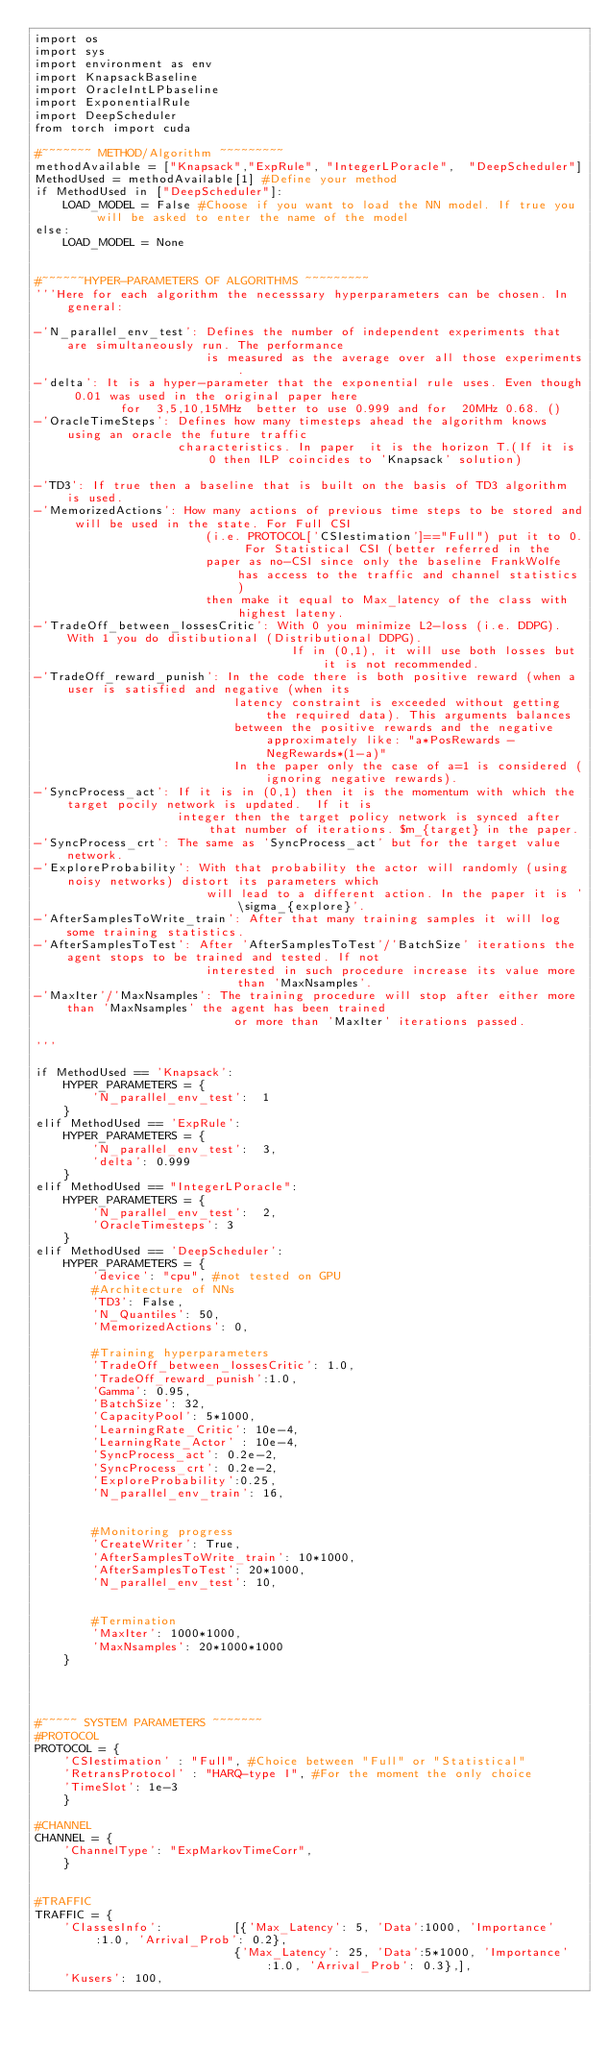<code> <loc_0><loc_0><loc_500><loc_500><_Python_>import os
import sys
import environment as env
import KnapsackBaseline
import OracleIntLPbaseline
import ExponentialRule
import DeepScheduler
from torch import cuda

#~~~~~~~ METHOD/Algorithm ~~~~~~~~~  
methodAvailable = ["Knapsack","ExpRule", "IntegerLPoracle",  "DeepScheduler"]
MethodUsed = methodAvailable[1] #Define your method
if MethodUsed in ["DeepScheduler"]:
    LOAD_MODEL = False #Choose if you want to load the NN model. If true you will be asked to enter the name of the model
else: 
    LOAD_MODEL = None


#~~~~~~HYPER-PARAMETERS OF ALGORITHMS ~~~~~~~~~
'''Here for each algorithm the necesssary hyperparameters can be chosen. In general:

-'N_parallel_env_test': Defines the number of independent experiments that are simultaneously run. The performance 
                        is measured as the average over all those experiments.
-'delta': It is a hyper-parameter that the exponential rule uses. Even though 0.01 was used in the original paper here
            for  3,5,10,15MHz  better to use 0.999 and for  20MHz 0.68. ()
-'OracleTimeSteps': Defines how many timesteps ahead the algorithm knows using an oracle the future traffic 
                    characteristics. In paper  it is the horizon T.(If it is 0 then ILP coincides to 'Knapsack' solution)

-'TD3': If true then a baseline that is built on the basis of TD3 algorithm is used.
-'MemorizedActions': How many actions of previous time steps to be stored and will be used in the state. For Full CSI
                        (i.e. PROTOCOL['CSIestimation']=="Full") put it to 0. For Statistical CSI (better referred in the
                        paper as no-CSI since only the baseline FrankWolfe has access to the traffic and channel statistics)
                        then make it equal to Max_latency of the class with highest lateny.
-'TradeOff_between_lossesCritic': With 0 you minimize L2-loss (i.e. DDPG). With 1 you do distibutional (Distributional DDPG). 
                                    If in (0,1), it will use both losses but it is not recommended.
-'TradeOff_reward_punish': In the code there is both positive reward (when a user is satisfied and negative (when its
                            latency constraint is exceeded without getting the required data). This arguments balances 
                            between the positive rewards and the negative approximately like: "a*PosRewards - NegRewards*(1-a)"
                            In the paper only the case of a=1 is considered (ignoring negative rewards).
-'SyncProcess_act': If it is in (0,1) then it is the momentum with which the target pocily network is updated.  If it is
                    integer then the target policy network is synced after that number of iterations. $m_{target} in the paper.
-'SyncProcess_crt': The same as 'SyncProcess_act' but for the target value network.
-'ExploreProbability': With that probability the actor will randomly (using noisy networks) distort its parameters which 
                        will lead to a different action. In the paper it is '\sigma_{explore}'.
-'AfterSamplesToWrite_train': After that many training samples it will log some training statistics.       
-'AfterSamplesToTest': After 'AfterSamplesToTest'/'BatchSize' iterations the agent stops to be trained and tested. If not 
                        interested in such procedure increase its value more than 'MaxNsamples'.
-'MaxIter'/'MaxNsamples': The training procedure will stop after either more than 'MaxNsamples' the agent has been trained
                            or more than 'MaxIter' iterations passed.                         

'''

if MethodUsed == 'Knapsack':
    HYPER_PARAMETERS = {
        'N_parallel_env_test':  1
    }
elif MethodUsed == 'ExpRule':
    HYPER_PARAMETERS = {
        'N_parallel_env_test':  3,
        'delta': 0.999
    }
elif MethodUsed == "IntegerLPoracle":
    HYPER_PARAMETERS = {
        'N_parallel_env_test':  2,
        'OracleTimesteps': 3
    }
elif MethodUsed == 'DeepScheduler':  
    HYPER_PARAMETERS = {
        'device': "cpu", #not tested on GPU
        #Architecture of NNs  
        'TD3': False,
        'N_Quantiles': 50,
        'MemorizedActions': 0, 

        #Training hyperparameters
        'TradeOff_between_lossesCritic': 1.0, 
        'TradeOff_reward_punish':1.0,   
        'Gamma': 0.95,    
        'BatchSize': 32,
        'CapacityPool': 5*1000, 
        'LearningRate_Critic': 10e-4,   
        'LearningRate_Actor' : 10e-4,    
        'SyncProcess_act': 0.2e-2,  
        'SyncProcess_crt': 0.2e-2,
        'ExploreProbability':0.25, 
        'N_parallel_env_train': 16,  


        #Monitoring progress
        'CreateWriter': True,       
        'AfterSamplesToWrite_train': 10*1000,            
        'AfterSamplesToTest': 20*1000,
        'N_parallel_env_test': 10,   


        #Termination   
        'MaxIter': 1000*1000, 
        'MaxNsamples': 20*1000*1000
    }    




#~~~~~ SYSTEM PARAMETERS ~~~~~~~
#PROTOCOL
PROTOCOL = {
    'CSIestimation' : "Full", #Choice between "Full" or "Statistical"
    'RetransProtocol' : "HARQ-type I", #For the moment the only choice 
    'TimeSlot': 1e-3
    }

#CHANNEL
CHANNEL = {
    'ChannelType': "ExpMarkovTimeCorr",
    }


#TRAFFIC
TRAFFIC = {    
    'ClassesInfo':          [{'Max_Latency': 5, 'Data':1000, 'Importance':1.0, 'Arrival_Prob': 0.2}, 
                            {'Max_Latency': 25, 'Data':5*1000, 'Importance':1.0, 'Arrival_Prob': 0.3},],   
    'Kusers': 100,</code> 